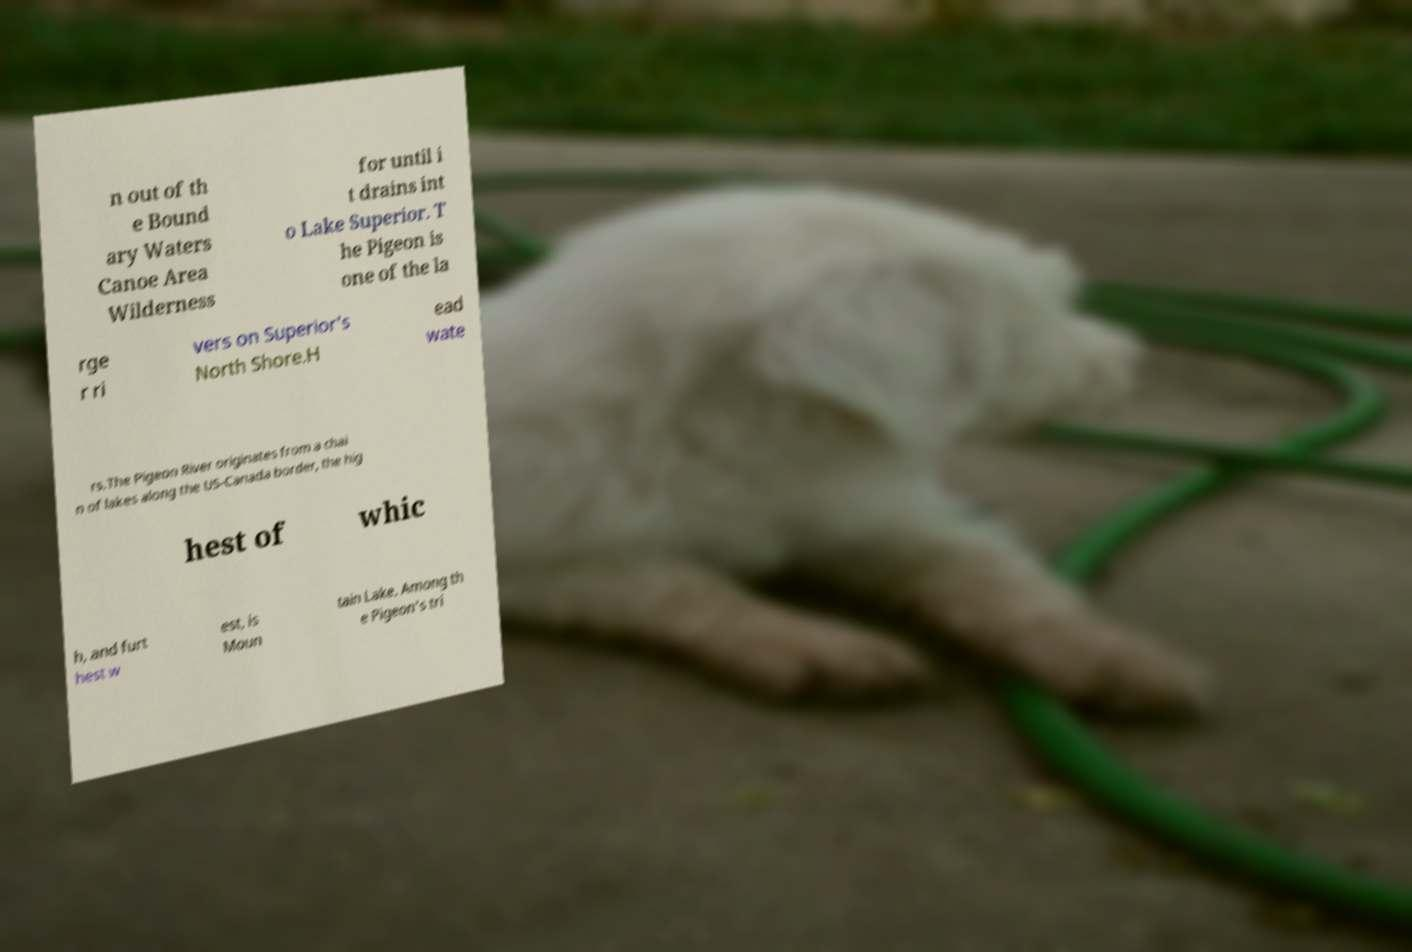What messages or text are displayed in this image? I need them in a readable, typed format. n out of th e Bound ary Waters Canoe Area Wilderness for until i t drains int o Lake Superior. T he Pigeon is one of the la rge r ri vers on Superior's North Shore.H ead wate rs.The Pigeon River originates from a chai n of lakes along the US-Canada border, the hig hest of whic h, and furt hest w est, is Moun tain Lake. Among th e Pigeon's tri 